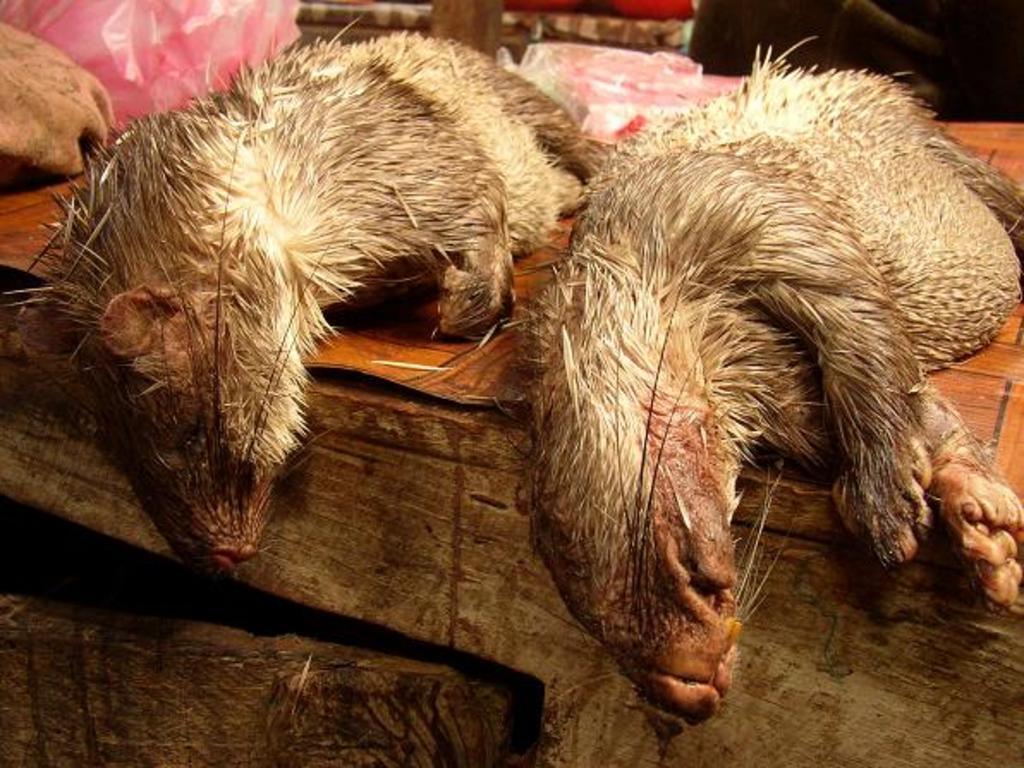Describe this image in one or two sentences. In the foreground of the picture we can see two animals on a wooden object. In the background there are covered and some other objects. 